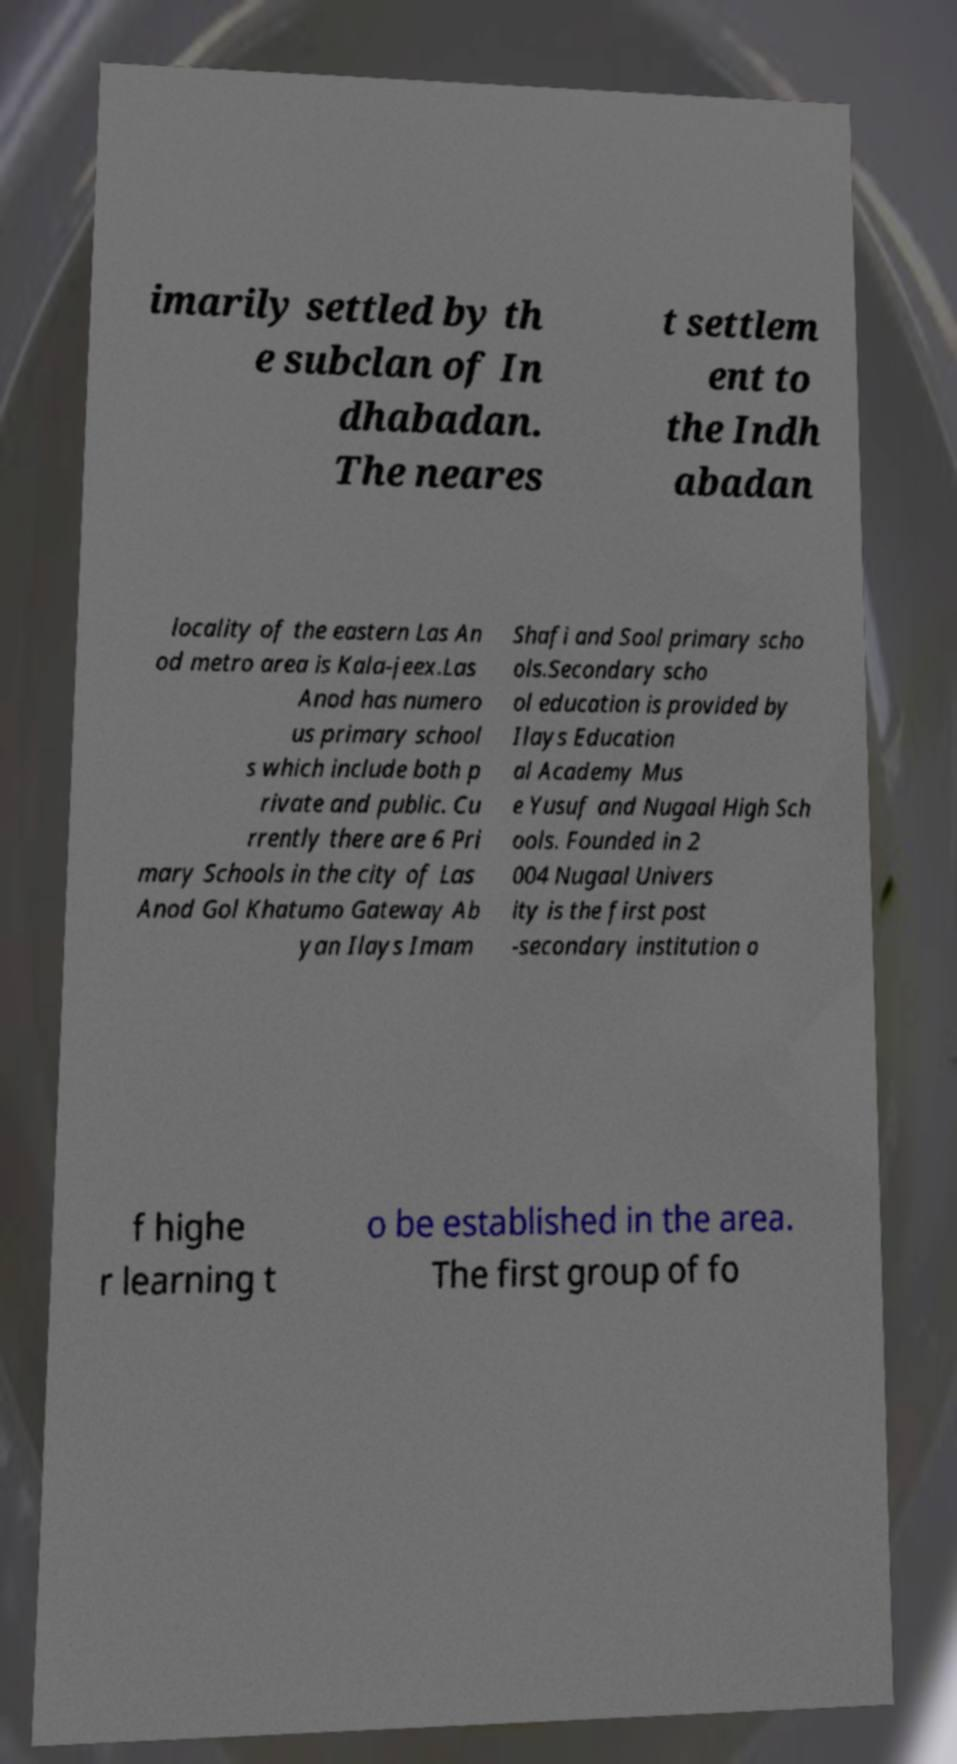Can you accurately transcribe the text from the provided image for me? imarily settled by th e subclan of In dhabadan. The neares t settlem ent to the Indh abadan locality of the eastern Las An od metro area is Kala-jeex.Las Anod has numero us primary school s which include both p rivate and public. Cu rrently there are 6 Pri mary Schools in the city of Las Anod Gol Khatumo Gateway Ab yan Ilays Imam Shafi and Sool primary scho ols.Secondary scho ol education is provided by Ilays Education al Academy Mus e Yusuf and Nugaal High Sch ools. Founded in 2 004 Nugaal Univers ity is the first post -secondary institution o f highe r learning t o be established in the area. The first group of fo 